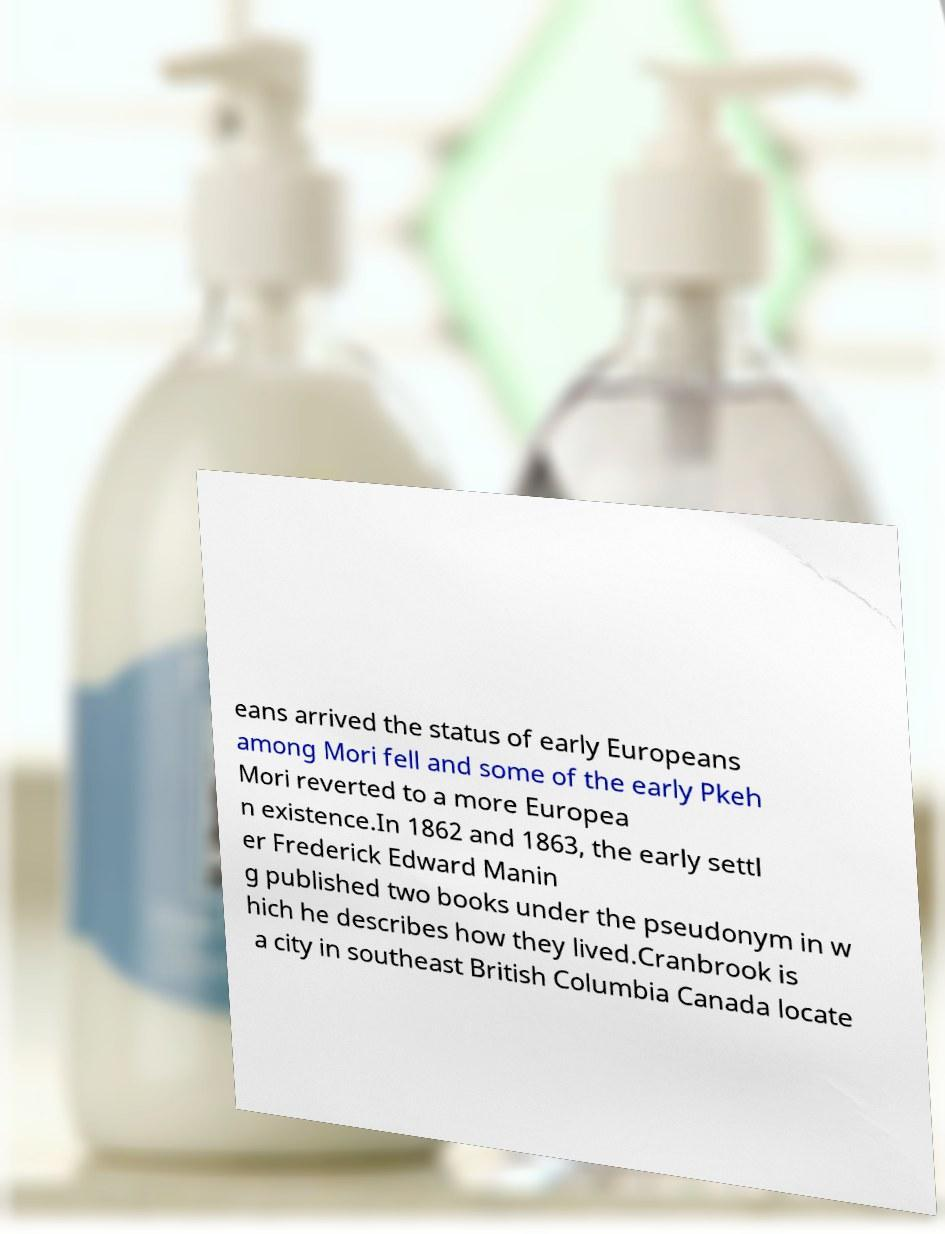For documentation purposes, I need the text within this image transcribed. Could you provide that? eans arrived the status of early Europeans among Mori fell and some of the early Pkeh Mori reverted to a more Europea n existence.In 1862 and 1863, the early settl er Frederick Edward Manin g published two books under the pseudonym in w hich he describes how they lived.Cranbrook is a city in southeast British Columbia Canada locate 